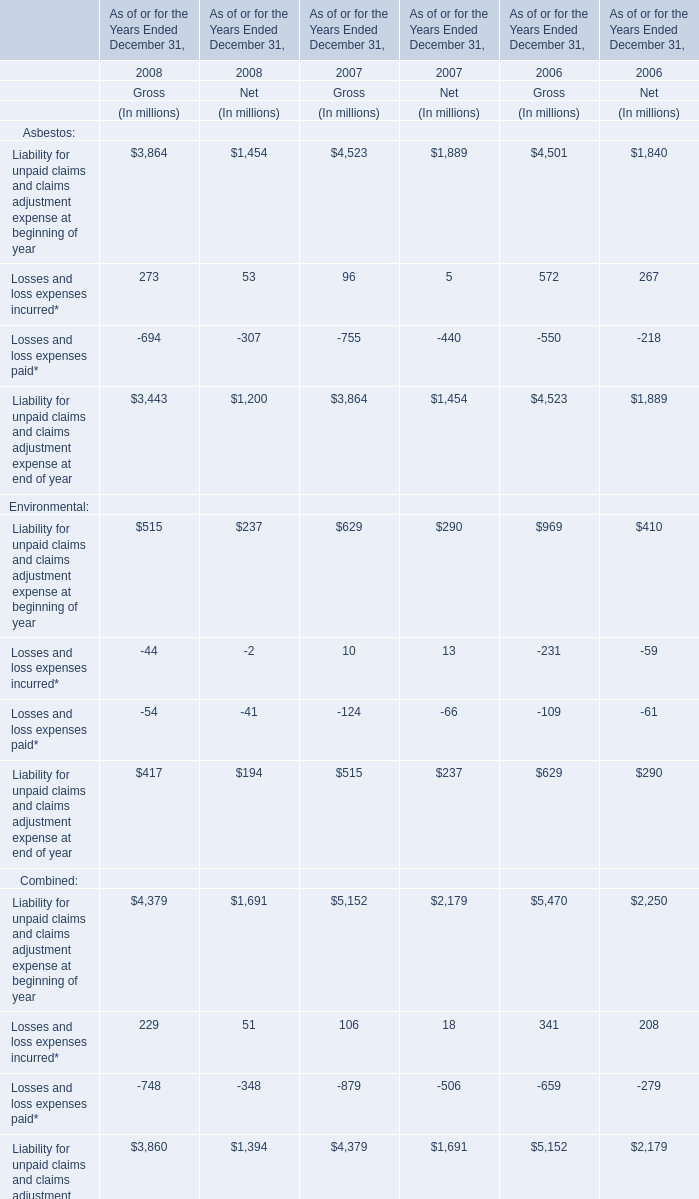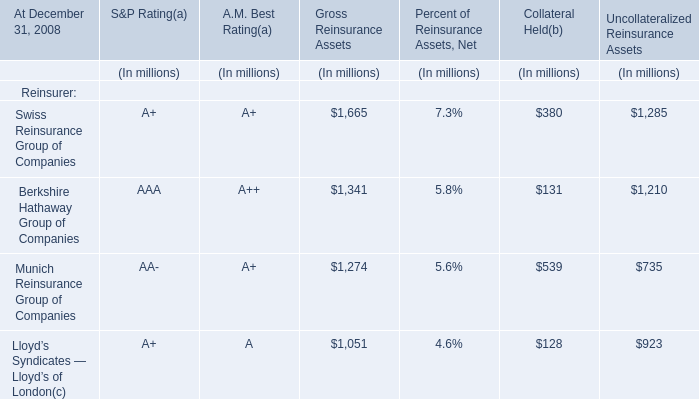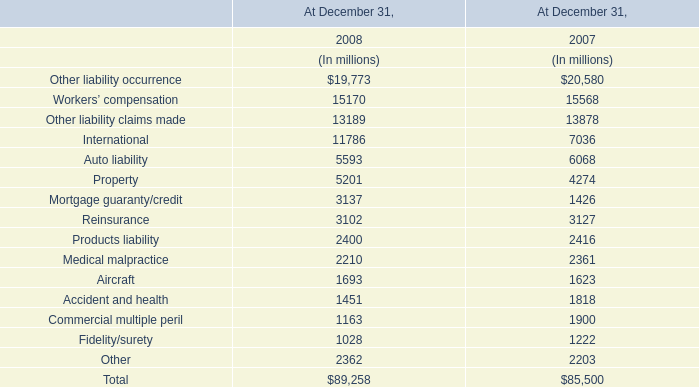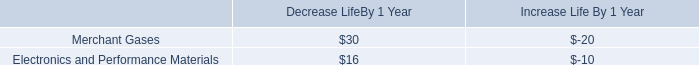What is the sum of Workers’ compensation in 2008 and Swiss Reinsurance Group of Companies for Collateral Held(b) ? 
Computations: (380 + 15170)
Answer: 15550.0. 